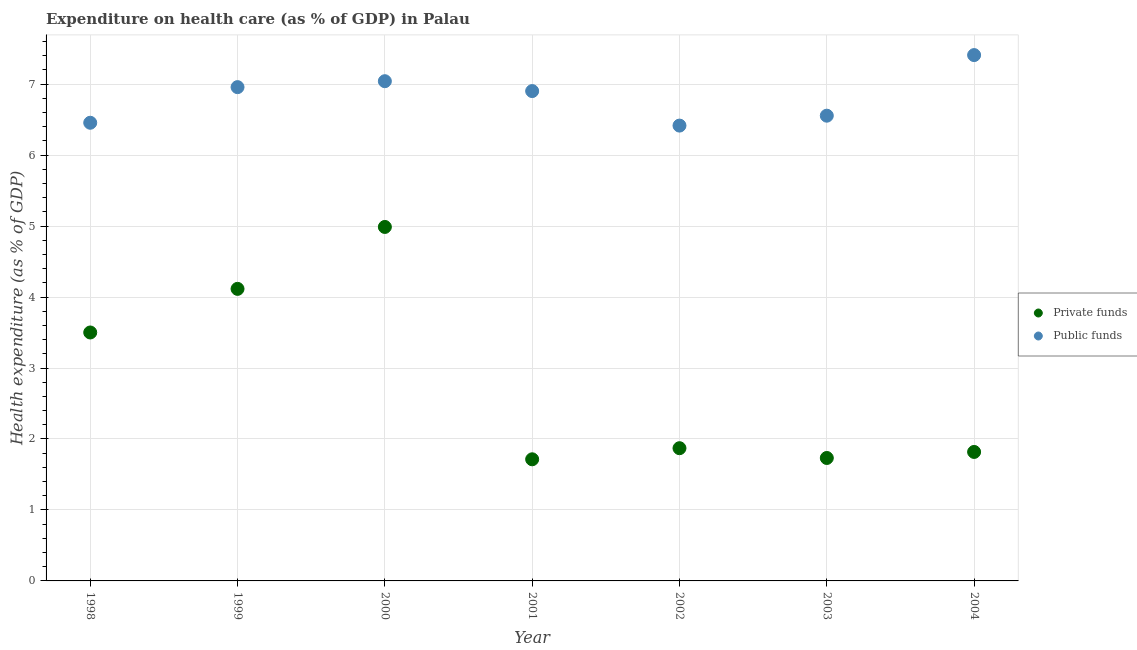How many different coloured dotlines are there?
Make the answer very short. 2. Is the number of dotlines equal to the number of legend labels?
Your answer should be very brief. Yes. What is the amount of public funds spent in healthcare in 2002?
Make the answer very short. 6.42. Across all years, what is the maximum amount of public funds spent in healthcare?
Ensure brevity in your answer.  7.41. Across all years, what is the minimum amount of private funds spent in healthcare?
Your answer should be very brief. 1.71. What is the total amount of public funds spent in healthcare in the graph?
Provide a short and direct response. 47.74. What is the difference between the amount of private funds spent in healthcare in 2000 and that in 2001?
Keep it short and to the point. 3.27. What is the difference between the amount of public funds spent in healthcare in 2001 and the amount of private funds spent in healthcare in 2002?
Provide a short and direct response. 5.03. What is the average amount of public funds spent in healthcare per year?
Your answer should be very brief. 6.82. In the year 2000, what is the difference between the amount of public funds spent in healthcare and amount of private funds spent in healthcare?
Your answer should be compact. 2.05. What is the ratio of the amount of public funds spent in healthcare in 1998 to that in 2004?
Make the answer very short. 0.87. Is the amount of private funds spent in healthcare in 2003 less than that in 2004?
Keep it short and to the point. Yes. What is the difference between the highest and the second highest amount of private funds spent in healthcare?
Offer a terse response. 0.87. What is the difference between the highest and the lowest amount of public funds spent in healthcare?
Your response must be concise. 0.99. Is the sum of the amount of public funds spent in healthcare in 1999 and 2004 greater than the maximum amount of private funds spent in healthcare across all years?
Provide a succinct answer. Yes. Is the amount of private funds spent in healthcare strictly greater than the amount of public funds spent in healthcare over the years?
Offer a very short reply. No. How many dotlines are there?
Your response must be concise. 2. How many years are there in the graph?
Your answer should be very brief. 7. What is the difference between two consecutive major ticks on the Y-axis?
Offer a very short reply. 1. Are the values on the major ticks of Y-axis written in scientific E-notation?
Provide a succinct answer. No. What is the title of the graph?
Offer a very short reply. Expenditure on health care (as % of GDP) in Palau. Does "Taxes" appear as one of the legend labels in the graph?
Your response must be concise. No. What is the label or title of the X-axis?
Give a very brief answer. Year. What is the label or title of the Y-axis?
Make the answer very short. Health expenditure (as % of GDP). What is the Health expenditure (as % of GDP) in Private funds in 1998?
Your answer should be very brief. 3.5. What is the Health expenditure (as % of GDP) in Public funds in 1998?
Make the answer very short. 6.46. What is the Health expenditure (as % of GDP) of Private funds in 1999?
Your response must be concise. 4.11. What is the Health expenditure (as % of GDP) in Public funds in 1999?
Your response must be concise. 6.96. What is the Health expenditure (as % of GDP) in Private funds in 2000?
Offer a very short reply. 4.99. What is the Health expenditure (as % of GDP) in Public funds in 2000?
Make the answer very short. 7.04. What is the Health expenditure (as % of GDP) of Private funds in 2001?
Your answer should be compact. 1.71. What is the Health expenditure (as % of GDP) of Public funds in 2001?
Provide a succinct answer. 6.9. What is the Health expenditure (as % of GDP) in Private funds in 2002?
Your answer should be compact. 1.87. What is the Health expenditure (as % of GDP) of Public funds in 2002?
Your answer should be very brief. 6.42. What is the Health expenditure (as % of GDP) in Private funds in 2003?
Provide a short and direct response. 1.73. What is the Health expenditure (as % of GDP) in Public funds in 2003?
Keep it short and to the point. 6.56. What is the Health expenditure (as % of GDP) of Private funds in 2004?
Your response must be concise. 1.82. What is the Health expenditure (as % of GDP) of Public funds in 2004?
Your answer should be very brief. 7.41. Across all years, what is the maximum Health expenditure (as % of GDP) of Private funds?
Offer a very short reply. 4.99. Across all years, what is the maximum Health expenditure (as % of GDP) in Public funds?
Give a very brief answer. 7.41. Across all years, what is the minimum Health expenditure (as % of GDP) of Private funds?
Provide a succinct answer. 1.71. Across all years, what is the minimum Health expenditure (as % of GDP) in Public funds?
Offer a very short reply. 6.42. What is the total Health expenditure (as % of GDP) in Private funds in the graph?
Provide a succinct answer. 19.74. What is the total Health expenditure (as % of GDP) in Public funds in the graph?
Your response must be concise. 47.74. What is the difference between the Health expenditure (as % of GDP) of Private funds in 1998 and that in 1999?
Give a very brief answer. -0.61. What is the difference between the Health expenditure (as % of GDP) in Public funds in 1998 and that in 1999?
Offer a terse response. -0.5. What is the difference between the Health expenditure (as % of GDP) of Private funds in 1998 and that in 2000?
Your answer should be very brief. -1.49. What is the difference between the Health expenditure (as % of GDP) in Public funds in 1998 and that in 2000?
Provide a short and direct response. -0.59. What is the difference between the Health expenditure (as % of GDP) in Private funds in 1998 and that in 2001?
Ensure brevity in your answer.  1.79. What is the difference between the Health expenditure (as % of GDP) of Public funds in 1998 and that in 2001?
Your answer should be compact. -0.45. What is the difference between the Health expenditure (as % of GDP) of Private funds in 1998 and that in 2002?
Give a very brief answer. 1.63. What is the difference between the Health expenditure (as % of GDP) in Private funds in 1998 and that in 2003?
Offer a very short reply. 1.77. What is the difference between the Health expenditure (as % of GDP) in Public funds in 1998 and that in 2003?
Your answer should be very brief. -0.1. What is the difference between the Health expenditure (as % of GDP) of Private funds in 1998 and that in 2004?
Provide a short and direct response. 1.68. What is the difference between the Health expenditure (as % of GDP) in Public funds in 1998 and that in 2004?
Ensure brevity in your answer.  -0.95. What is the difference between the Health expenditure (as % of GDP) in Private funds in 1999 and that in 2000?
Provide a succinct answer. -0.87. What is the difference between the Health expenditure (as % of GDP) of Public funds in 1999 and that in 2000?
Offer a very short reply. -0.08. What is the difference between the Health expenditure (as % of GDP) in Private funds in 1999 and that in 2001?
Your answer should be compact. 2.4. What is the difference between the Health expenditure (as % of GDP) of Public funds in 1999 and that in 2001?
Give a very brief answer. 0.06. What is the difference between the Health expenditure (as % of GDP) in Private funds in 1999 and that in 2002?
Offer a very short reply. 2.24. What is the difference between the Health expenditure (as % of GDP) in Public funds in 1999 and that in 2002?
Make the answer very short. 0.54. What is the difference between the Health expenditure (as % of GDP) in Private funds in 1999 and that in 2003?
Your answer should be very brief. 2.38. What is the difference between the Health expenditure (as % of GDP) of Public funds in 1999 and that in 2003?
Keep it short and to the point. 0.4. What is the difference between the Health expenditure (as % of GDP) in Private funds in 1999 and that in 2004?
Offer a very short reply. 2.3. What is the difference between the Health expenditure (as % of GDP) of Public funds in 1999 and that in 2004?
Your response must be concise. -0.45. What is the difference between the Health expenditure (as % of GDP) in Private funds in 2000 and that in 2001?
Offer a very short reply. 3.27. What is the difference between the Health expenditure (as % of GDP) in Public funds in 2000 and that in 2001?
Your answer should be compact. 0.14. What is the difference between the Health expenditure (as % of GDP) of Private funds in 2000 and that in 2002?
Provide a succinct answer. 3.12. What is the difference between the Health expenditure (as % of GDP) in Public funds in 2000 and that in 2002?
Make the answer very short. 0.63. What is the difference between the Health expenditure (as % of GDP) of Private funds in 2000 and that in 2003?
Your response must be concise. 3.26. What is the difference between the Health expenditure (as % of GDP) in Public funds in 2000 and that in 2003?
Ensure brevity in your answer.  0.49. What is the difference between the Health expenditure (as % of GDP) of Private funds in 2000 and that in 2004?
Offer a very short reply. 3.17. What is the difference between the Health expenditure (as % of GDP) in Public funds in 2000 and that in 2004?
Provide a succinct answer. -0.37. What is the difference between the Health expenditure (as % of GDP) of Private funds in 2001 and that in 2002?
Provide a short and direct response. -0.16. What is the difference between the Health expenditure (as % of GDP) in Public funds in 2001 and that in 2002?
Ensure brevity in your answer.  0.49. What is the difference between the Health expenditure (as % of GDP) of Private funds in 2001 and that in 2003?
Make the answer very short. -0.02. What is the difference between the Health expenditure (as % of GDP) of Public funds in 2001 and that in 2003?
Provide a succinct answer. 0.35. What is the difference between the Health expenditure (as % of GDP) in Private funds in 2001 and that in 2004?
Make the answer very short. -0.1. What is the difference between the Health expenditure (as % of GDP) in Public funds in 2001 and that in 2004?
Ensure brevity in your answer.  -0.51. What is the difference between the Health expenditure (as % of GDP) of Private funds in 2002 and that in 2003?
Offer a terse response. 0.14. What is the difference between the Health expenditure (as % of GDP) of Public funds in 2002 and that in 2003?
Your response must be concise. -0.14. What is the difference between the Health expenditure (as % of GDP) of Private funds in 2002 and that in 2004?
Provide a short and direct response. 0.05. What is the difference between the Health expenditure (as % of GDP) in Public funds in 2002 and that in 2004?
Keep it short and to the point. -0.99. What is the difference between the Health expenditure (as % of GDP) of Private funds in 2003 and that in 2004?
Make the answer very short. -0.09. What is the difference between the Health expenditure (as % of GDP) in Public funds in 2003 and that in 2004?
Provide a short and direct response. -0.85. What is the difference between the Health expenditure (as % of GDP) in Private funds in 1998 and the Health expenditure (as % of GDP) in Public funds in 1999?
Keep it short and to the point. -3.46. What is the difference between the Health expenditure (as % of GDP) in Private funds in 1998 and the Health expenditure (as % of GDP) in Public funds in 2000?
Offer a very short reply. -3.54. What is the difference between the Health expenditure (as % of GDP) of Private funds in 1998 and the Health expenditure (as % of GDP) of Public funds in 2001?
Your response must be concise. -3.4. What is the difference between the Health expenditure (as % of GDP) in Private funds in 1998 and the Health expenditure (as % of GDP) in Public funds in 2002?
Offer a terse response. -2.92. What is the difference between the Health expenditure (as % of GDP) in Private funds in 1998 and the Health expenditure (as % of GDP) in Public funds in 2003?
Offer a terse response. -3.05. What is the difference between the Health expenditure (as % of GDP) of Private funds in 1998 and the Health expenditure (as % of GDP) of Public funds in 2004?
Your answer should be very brief. -3.91. What is the difference between the Health expenditure (as % of GDP) of Private funds in 1999 and the Health expenditure (as % of GDP) of Public funds in 2000?
Make the answer very short. -2.93. What is the difference between the Health expenditure (as % of GDP) in Private funds in 1999 and the Health expenditure (as % of GDP) in Public funds in 2001?
Make the answer very short. -2.79. What is the difference between the Health expenditure (as % of GDP) of Private funds in 1999 and the Health expenditure (as % of GDP) of Public funds in 2002?
Ensure brevity in your answer.  -2.3. What is the difference between the Health expenditure (as % of GDP) in Private funds in 1999 and the Health expenditure (as % of GDP) in Public funds in 2003?
Your answer should be very brief. -2.44. What is the difference between the Health expenditure (as % of GDP) of Private funds in 1999 and the Health expenditure (as % of GDP) of Public funds in 2004?
Keep it short and to the point. -3.29. What is the difference between the Health expenditure (as % of GDP) in Private funds in 2000 and the Health expenditure (as % of GDP) in Public funds in 2001?
Your answer should be compact. -1.91. What is the difference between the Health expenditure (as % of GDP) in Private funds in 2000 and the Health expenditure (as % of GDP) in Public funds in 2002?
Offer a terse response. -1.43. What is the difference between the Health expenditure (as % of GDP) of Private funds in 2000 and the Health expenditure (as % of GDP) of Public funds in 2003?
Your answer should be very brief. -1.57. What is the difference between the Health expenditure (as % of GDP) in Private funds in 2000 and the Health expenditure (as % of GDP) in Public funds in 2004?
Offer a very short reply. -2.42. What is the difference between the Health expenditure (as % of GDP) of Private funds in 2001 and the Health expenditure (as % of GDP) of Public funds in 2002?
Your answer should be very brief. -4.7. What is the difference between the Health expenditure (as % of GDP) in Private funds in 2001 and the Health expenditure (as % of GDP) in Public funds in 2003?
Make the answer very short. -4.84. What is the difference between the Health expenditure (as % of GDP) in Private funds in 2001 and the Health expenditure (as % of GDP) in Public funds in 2004?
Give a very brief answer. -5.7. What is the difference between the Health expenditure (as % of GDP) in Private funds in 2002 and the Health expenditure (as % of GDP) in Public funds in 2003?
Provide a succinct answer. -4.69. What is the difference between the Health expenditure (as % of GDP) in Private funds in 2002 and the Health expenditure (as % of GDP) in Public funds in 2004?
Keep it short and to the point. -5.54. What is the difference between the Health expenditure (as % of GDP) of Private funds in 2003 and the Health expenditure (as % of GDP) of Public funds in 2004?
Keep it short and to the point. -5.68. What is the average Health expenditure (as % of GDP) in Private funds per year?
Your response must be concise. 2.82. What is the average Health expenditure (as % of GDP) in Public funds per year?
Make the answer very short. 6.82. In the year 1998, what is the difference between the Health expenditure (as % of GDP) of Private funds and Health expenditure (as % of GDP) of Public funds?
Keep it short and to the point. -2.96. In the year 1999, what is the difference between the Health expenditure (as % of GDP) in Private funds and Health expenditure (as % of GDP) in Public funds?
Offer a very short reply. -2.84. In the year 2000, what is the difference between the Health expenditure (as % of GDP) of Private funds and Health expenditure (as % of GDP) of Public funds?
Keep it short and to the point. -2.05. In the year 2001, what is the difference between the Health expenditure (as % of GDP) of Private funds and Health expenditure (as % of GDP) of Public funds?
Your answer should be compact. -5.19. In the year 2002, what is the difference between the Health expenditure (as % of GDP) of Private funds and Health expenditure (as % of GDP) of Public funds?
Provide a succinct answer. -4.55. In the year 2003, what is the difference between the Health expenditure (as % of GDP) in Private funds and Health expenditure (as % of GDP) in Public funds?
Ensure brevity in your answer.  -4.82. In the year 2004, what is the difference between the Health expenditure (as % of GDP) of Private funds and Health expenditure (as % of GDP) of Public funds?
Provide a short and direct response. -5.59. What is the ratio of the Health expenditure (as % of GDP) in Private funds in 1998 to that in 1999?
Offer a very short reply. 0.85. What is the ratio of the Health expenditure (as % of GDP) of Public funds in 1998 to that in 1999?
Give a very brief answer. 0.93. What is the ratio of the Health expenditure (as % of GDP) of Private funds in 1998 to that in 2000?
Keep it short and to the point. 0.7. What is the ratio of the Health expenditure (as % of GDP) of Public funds in 1998 to that in 2000?
Make the answer very short. 0.92. What is the ratio of the Health expenditure (as % of GDP) in Private funds in 1998 to that in 2001?
Provide a succinct answer. 2.04. What is the ratio of the Health expenditure (as % of GDP) of Public funds in 1998 to that in 2001?
Offer a very short reply. 0.94. What is the ratio of the Health expenditure (as % of GDP) of Private funds in 1998 to that in 2002?
Offer a very short reply. 1.87. What is the ratio of the Health expenditure (as % of GDP) in Public funds in 1998 to that in 2002?
Provide a short and direct response. 1.01. What is the ratio of the Health expenditure (as % of GDP) in Private funds in 1998 to that in 2003?
Offer a terse response. 2.02. What is the ratio of the Health expenditure (as % of GDP) of Public funds in 1998 to that in 2003?
Your response must be concise. 0.98. What is the ratio of the Health expenditure (as % of GDP) of Private funds in 1998 to that in 2004?
Provide a succinct answer. 1.93. What is the ratio of the Health expenditure (as % of GDP) of Public funds in 1998 to that in 2004?
Your answer should be very brief. 0.87. What is the ratio of the Health expenditure (as % of GDP) in Private funds in 1999 to that in 2000?
Make the answer very short. 0.83. What is the ratio of the Health expenditure (as % of GDP) of Public funds in 1999 to that in 2000?
Offer a terse response. 0.99. What is the ratio of the Health expenditure (as % of GDP) of Private funds in 1999 to that in 2001?
Your answer should be compact. 2.4. What is the ratio of the Health expenditure (as % of GDP) of Public funds in 1999 to that in 2001?
Ensure brevity in your answer.  1.01. What is the ratio of the Health expenditure (as % of GDP) in Private funds in 1999 to that in 2002?
Offer a terse response. 2.2. What is the ratio of the Health expenditure (as % of GDP) in Public funds in 1999 to that in 2002?
Keep it short and to the point. 1.08. What is the ratio of the Health expenditure (as % of GDP) in Private funds in 1999 to that in 2003?
Your response must be concise. 2.38. What is the ratio of the Health expenditure (as % of GDP) in Public funds in 1999 to that in 2003?
Keep it short and to the point. 1.06. What is the ratio of the Health expenditure (as % of GDP) in Private funds in 1999 to that in 2004?
Make the answer very short. 2.26. What is the ratio of the Health expenditure (as % of GDP) in Public funds in 1999 to that in 2004?
Offer a terse response. 0.94. What is the ratio of the Health expenditure (as % of GDP) in Private funds in 2000 to that in 2001?
Ensure brevity in your answer.  2.91. What is the ratio of the Health expenditure (as % of GDP) of Public funds in 2000 to that in 2001?
Your response must be concise. 1.02. What is the ratio of the Health expenditure (as % of GDP) in Private funds in 2000 to that in 2002?
Make the answer very short. 2.67. What is the ratio of the Health expenditure (as % of GDP) in Public funds in 2000 to that in 2002?
Keep it short and to the point. 1.1. What is the ratio of the Health expenditure (as % of GDP) in Private funds in 2000 to that in 2003?
Give a very brief answer. 2.88. What is the ratio of the Health expenditure (as % of GDP) in Public funds in 2000 to that in 2003?
Keep it short and to the point. 1.07. What is the ratio of the Health expenditure (as % of GDP) of Private funds in 2000 to that in 2004?
Offer a very short reply. 2.74. What is the ratio of the Health expenditure (as % of GDP) of Public funds in 2000 to that in 2004?
Offer a terse response. 0.95. What is the ratio of the Health expenditure (as % of GDP) of Private funds in 2001 to that in 2002?
Make the answer very short. 0.92. What is the ratio of the Health expenditure (as % of GDP) of Public funds in 2001 to that in 2002?
Your answer should be compact. 1.08. What is the ratio of the Health expenditure (as % of GDP) in Private funds in 2001 to that in 2003?
Your response must be concise. 0.99. What is the ratio of the Health expenditure (as % of GDP) of Public funds in 2001 to that in 2003?
Your answer should be compact. 1.05. What is the ratio of the Health expenditure (as % of GDP) in Private funds in 2001 to that in 2004?
Keep it short and to the point. 0.94. What is the ratio of the Health expenditure (as % of GDP) in Public funds in 2001 to that in 2004?
Your answer should be compact. 0.93. What is the ratio of the Health expenditure (as % of GDP) of Private funds in 2002 to that in 2003?
Your response must be concise. 1.08. What is the ratio of the Health expenditure (as % of GDP) of Public funds in 2002 to that in 2003?
Offer a very short reply. 0.98. What is the ratio of the Health expenditure (as % of GDP) of Public funds in 2002 to that in 2004?
Provide a succinct answer. 0.87. What is the ratio of the Health expenditure (as % of GDP) of Private funds in 2003 to that in 2004?
Your answer should be very brief. 0.95. What is the ratio of the Health expenditure (as % of GDP) in Public funds in 2003 to that in 2004?
Your answer should be very brief. 0.88. What is the difference between the highest and the second highest Health expenditure (as % of GDP) of Private funds?
Provide a succinct answer. 0.87. What is the difference between the highest and the second highest Health expenditure (as % of GDP) of Public funds?
Give a very brief answer. 0.37. What is the difference between the highest and the lowest Health expenditure (as % of GDP) in Private funds?
Provide a succinct answer. 3.27. 